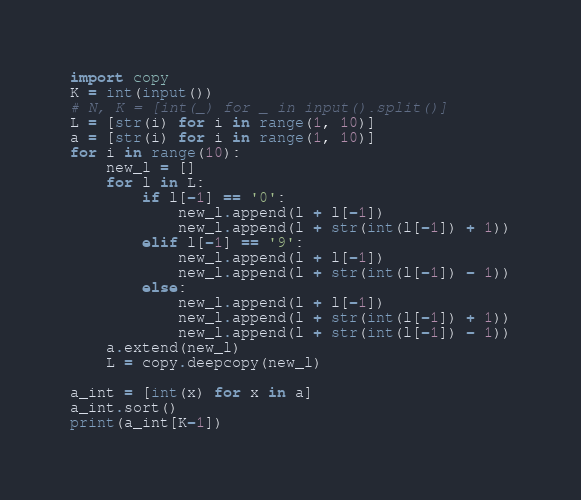Convert code to text. <code><loc_0><loc_0><loc_500><loc_500><_Python_>import copy
K = int(input())
# N, K = [int(_) for _ in input().split()]
L = [str(i) for i in range(1, 10)]
a = [str(i) for i in range(1, 10)]
for i in range(10):
    new_l = []
    for l in L:
        if l[-1] == '0':
            new_l.append(l + l[-1])
            new_l.append(l + str(int(l[-1]) + 1))
        elif l[-1] == '9':
            new_l.append(l + l[-1])
            new_l.append(l + str(int(l[-1]) - 1))
        else:
            new_l.append(l + l[-1])
            new_l.append(l + str(int(l[-1]) + 1))
            new_l.append(l + str(int(l[-1]) - 1))
    a.extend(new_l)
    L = copy.deepcopy(new_l)

a_int = [int(x) for x in a]
a_int.sort()
print(a_int[K-1])
</code> 